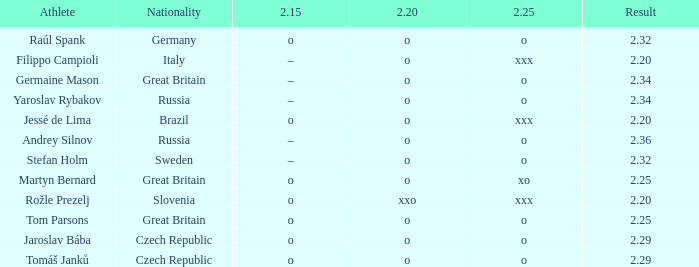Which athlete from Brazil has 2.20 O and 2.25 of XXX? Jessé de Lima. 